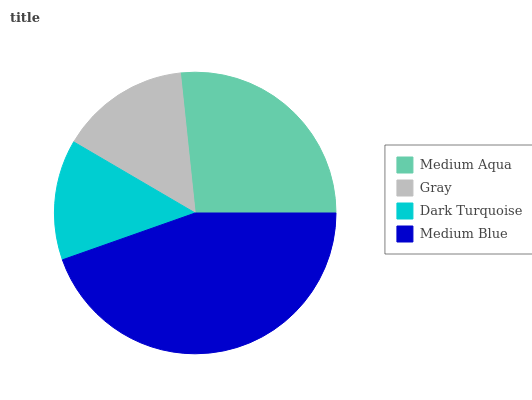Is Dark Turquoise the minimum?
Answer yes or no. Yes. Is Medium Blue the maximum?
Answer yes or no. Yes. Is Gray the minimum?
Answer yes or no. No. Is Gray the maximum?
Answer yes or no. No. Is Medium Aqua greater than Gray?
Answer yes or no. Yes. Is Gray less than Medium Aqua?
Answer yes or no. Yes. Is Gray greater than Medium Aqua?
Answer yes or no. No. Is Medium Aqua less than Gray?
Answer yes or no. No. Is Medium Aqua the high median?
Answer yes or no. Yes. Is Gray the low median?
Answer yes or no. Yes. Is Gray the high median?
Answer yes or no. No. Is Dark Turquoise the low median?
Answer yes or no. No. 